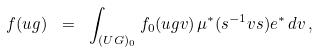<formula> <loc_0><loc_0><loc_500><loc_500>f ( u g ) \ = \ \int _ { ( U G ) _ { 0 } } f _ { 0 } ( u g v ) \, \mu ^ { * } ( s ^ { - 1 } v s ) e ^ { * } \, d v \, ,</formula> 